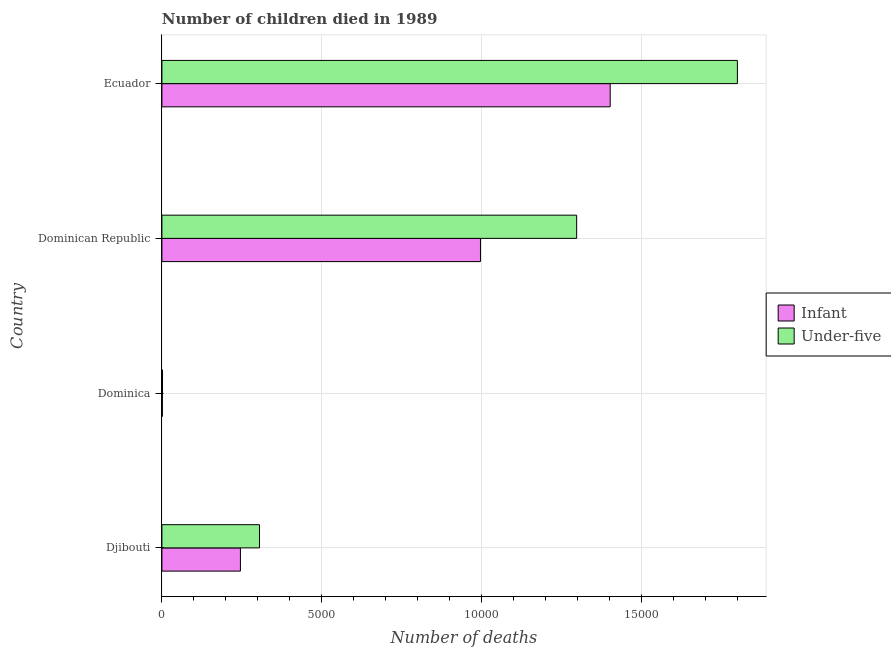How many bars are there on the 1st tick from the top?
Ensure brevity in your answer.  2. What is the label of the 4th group of bars from the top?
Your response must be concise. Djibouti. In how many cases, is the number of bars for a given country not equal to the number of legend labels?
Keep it short and to the point. 0. What is the number of infant deaths in Ecuador?
Keep it short and to the point. 1.40e+04. Across all countries, what is the maximum number of infant deaths?
Your answer should be very brief. 1.40e+04. Across all countries, what is the minimum number of infant deaths?
Keep it short and to the point. 15. In which country was the number of infant deaths maximum?
Ensure brevity in your answer.  Ecuador. In which country was the number of infant deaths minimum?
Keep it short and to the point. Dominica. What is the total number of infant deaths in the graph?
Keep it short and to the point. 2.65e+04. What is the difference between the number of infant deaths in Djibouti and that in Dominican Republic?
Make the answer very short. -7511. What is the difference between the number of infant deaths in Dominican Republic and the number of under-five deaths in Djibouti?
Offer a terse response. 6914. What is the average number of under-five deaths per country?
Make the answer very short. 8514. What is the difference between the number of under-five deaths and number of infant deaths in Djibouti?
Provide a short and direct response. 597. In how many countries, is the number of under-five deaths greater than 17000 ?
Keep it short and to the point. 1. What is the ratio of the number of infant deaths in Djibouti to that in Dominica?
Provide a short and direct response. 163.8. What is the difference between the highest and the second highest number of under-five deaths?
Your answer should be compact. 5029. What is the difference between the highest and the lowest number of under-five deaths?
Your answer should be very brief. 1.80e+04. In how many countries, is the number of infant deaths greater than the average number of infant deaths taken over all countries?
Offer a terse response. 2. Is the sum of the number of under-five deaths in Djibouti and Dominican Republic greater than the maximum number of infant deaths across all countries?
Your response must be concise. Yes. What does the 1st bar from the top in Dominica represents?
Provide a succinct answer. Under-five. What does the 2nd bar from the bottom in Djibouti represents?
Provide a succinct answer. Under-five. How many bars are there?
Keep it short and to the point. 8. Are all the bars in the graph horizontal?
Keep it short and to the point. Yes. Does the graph contain any zero values?
Your response must be concise. No. Where does the legend appear in the graph?
Provide a short and direct response. Center right. How many legend labels are there?
Provide a short and direct response. 2. How are the legend labels stacked?
Your answer should be compact. Vertical. What is the title of the graph?
Make the answer very short. Number of children died in 1989. What is the label or title of the X-axis?
Your response must be concise. Number of deaths. What is the Number of deaths of Infant in Djibouti?
Your response must be concise. 2457. What is the Number of deaths in Under-five in Djibouti?
Your answer should be compact. 3054. What is the Number of deaths of Infant in Dominica?
Your answer should be very brief. 15. What is the Number of deaths in Under-five in Dominica?
Your answer should be very brief. 19. What is the Number of deaths in Infant in Dominican Republic?
Offer a very short reply. 9968. What is the Number of deaths in Under-five in Dominican Republic?
Give a very brief answer. 1.30e+04. What is the Number of deaths in Infant in Ecuador?
Provide a succinct answer. 1.40e+04. What is the Number of deaths of Under-five in Ecuador?
Make the answer very short. 1.80e+04. Across all countries, what is the maximum Number of deaths in Infant?
Offer a very short reply. 1.40e+04. Across all countries, what is the maximum Number of deaths of Under-five?
Offer a very short reply. 1.80e+04. Across all countries, what is the minimum Number of deaths in Infant?
Your answer should be very brief. 15. Across all countries, what is the minimum Number of deaths in Under-five?
Offer a very short reply. 19. What is the total Number of deaths in Infant in the graph?
Offer a terse response. 2.65e+04. What is the total Number of deaths in Under-five in the graph?
Provide a succinct answer. 3.41e+04. What is the difference between the Number of deaths of Infant in Djibouti and that in Dominica?
Provide a short and direct response. 2442. What is the difference between the Number of deaths of Under-five in Djibouti and that in Dominica?
Offer a very short reply. 3035. What is the difference between the Number of deaths in Infant in Djibouti and that in Dominican Republic?
Provide a short and direct response. -7511. What is the difference between the Number of deaths in Under-five in Djibouti and that in Dominican Republic?
Offer a terse response. -9923. What is the difference between the Number of deaths of Infant in Djibouti and that in Ecuador?
Provide a short and direct response. -1.16e+04. What is the difference between the Number of deaths of Under-five in Djibouti and that in Ecuador?
Provide a short and direct response. -1.50e+04. What is the difference between the Number of deaths in Infant in Dominica and that in Dominican Republic?
Offer a very short reply. -9953. What is the difference between the Number of deaths in Under-five in Dominica and that in Dominican Republic?
Keep it short and to the point. -1.30e+04. What is the difference between the Number of deaths of Infant in Dominica and that in Ecuador?
Ensure brevity in your answer.  -1.40e+04. What is the difference between the Number of deaths of Under-five in Dominica and that in Ecuador?
Your answer should be compact. -1.80e+04. What is the difference between the Number of deaths in Infant in Dominican Republic and that in Ecuador?
Your response must be concise. -4058. What is the difference between the Number of deaths in Under-five in Dominican Republic and that in Ecuador?
Ensure brevity in your answer.  -5029. What is the difference between the Number of deaths of Infant in Djibouti and the Number of deaths of Under-five in Dominica?
Your response must be concise. 2438. What is the difference between the Number of deaths in Infant in Djibouti and the Number of deaths in Under-five in Dominican Republic?
Offer a terse response. -1.05e+04. What is the difference between the Number of deaths of Infant in Djibouti and the Number of deaths of Under-five in Ecuador?
Your answer should be very brief. -1.55e+04. What is the difference between the Number of deaths of Infant in Dominica and the Number of deaths of Under-five in Dominican Republic?
Offer a terse response. -1.30e+04. What is the difference between the Number of deaths in Infant in Dominica and the Number of deaths in Under-five in Ecuador?
Give a very brief answer. -1.80e+04. What is the difference between the Number of deaths in Infant in Dominican Republic and the Number of deaths in Under-five in Ecuador?
Make the answer very short. -8038. What is the average Number of deaths in Infant per country?
Offer a terse response. 6616.5. What is the average Number of deaths of Under-five per country?
Offer a very short reply. 8514. What is the difference between the Number of deaths of Infant and Number of deaths of Under-five in Djibouti?
Give a very brief answer. -597. What is the difference between the Number of deaths of Infant and Number of deaths of Under-five in Dominica?
Make the answer very short. -4. What is the difference between the Number of deaths in Infant and Number of deaths in Under-five in Dominican Republic?
Offer a terse response. -3009. What is the difference between the Number of deaths in Infant and Number of deaths in Under-five in Ecuador?
Provide a succinct answer. -3980. What is the ratio of the Number of deaths in Infant in Djibouti to that in Dominica?
Your answer should be compact. 163.8. What is the ratio of the Number of deaths of Under-five in Djibouti to that in Dominica?
Keep it short and to the point. 160.74. What is the ratio of the Number of deaths of Infant in Djibouti to that in Dominican Republic?
Provide a succinct answer. 0.25. What is the ratio of the Number of deaths of Under-five in Djibouti to that in Dominican Republic?
Your answer should be very brief. 0.24. What is the ratio of the Number of deaths in Infant in Djibouti to that in Ecuador?
Provide a succinct answer. 0.18. What is the ratio of the Number of deaths of Under-five in Djibouti to that in Ecuador?
Offer a very short reply. 0.17. What is the ratio of the Number of deaths in Infant in Dominica to that in Dominican Republic?
Give a very brief answer. 0. What is the ratio of the Number of deaths in Under-five in Dominica to that in Dominican Republic?
Give a very brief answer. 0. What is the ratio of the Number of deaths in Infant in Dominica to that in Ecuador?
Your answer should be compact. 0. What is the ratio of the Number of deaths of Under-five in Dominica to that in Ecuador?
Your response must be concise. 0. What is the ratio of the Number of deaths in Infant in Dominican Republic to that in Ecuador?
Provide a succinct answer. 0.71. What is the ratio of the Number of deaths of Under-five in Dominican Republic to that in Ecuador?
Ensure brevity in your answer.  0.72. What is the difference between the highest and the second highest Number of deaths of Infant?
Your response must be concise. 4058. What is the difference between the highest and the second highest Number of deaths of Under-five?
Provide a succinct answer. 5029. What is the difference between the highest and the lowest Number of deaths of Infant?
Your answer should be compact. 1.40e+04. What is the difference between the highest and the lowest Number of deaths of Under-five?
Ensure brevity in your answer.  1.80e+04. 